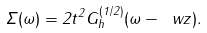<formula> <loc_0><loc_0><loc_500><loc_500>\Sigma ( \omega ) = 2 t ^ { 2 } G ^ { ( 1 / 2 ) } _ { h } ( \omega - \ w z ) .</formula> 